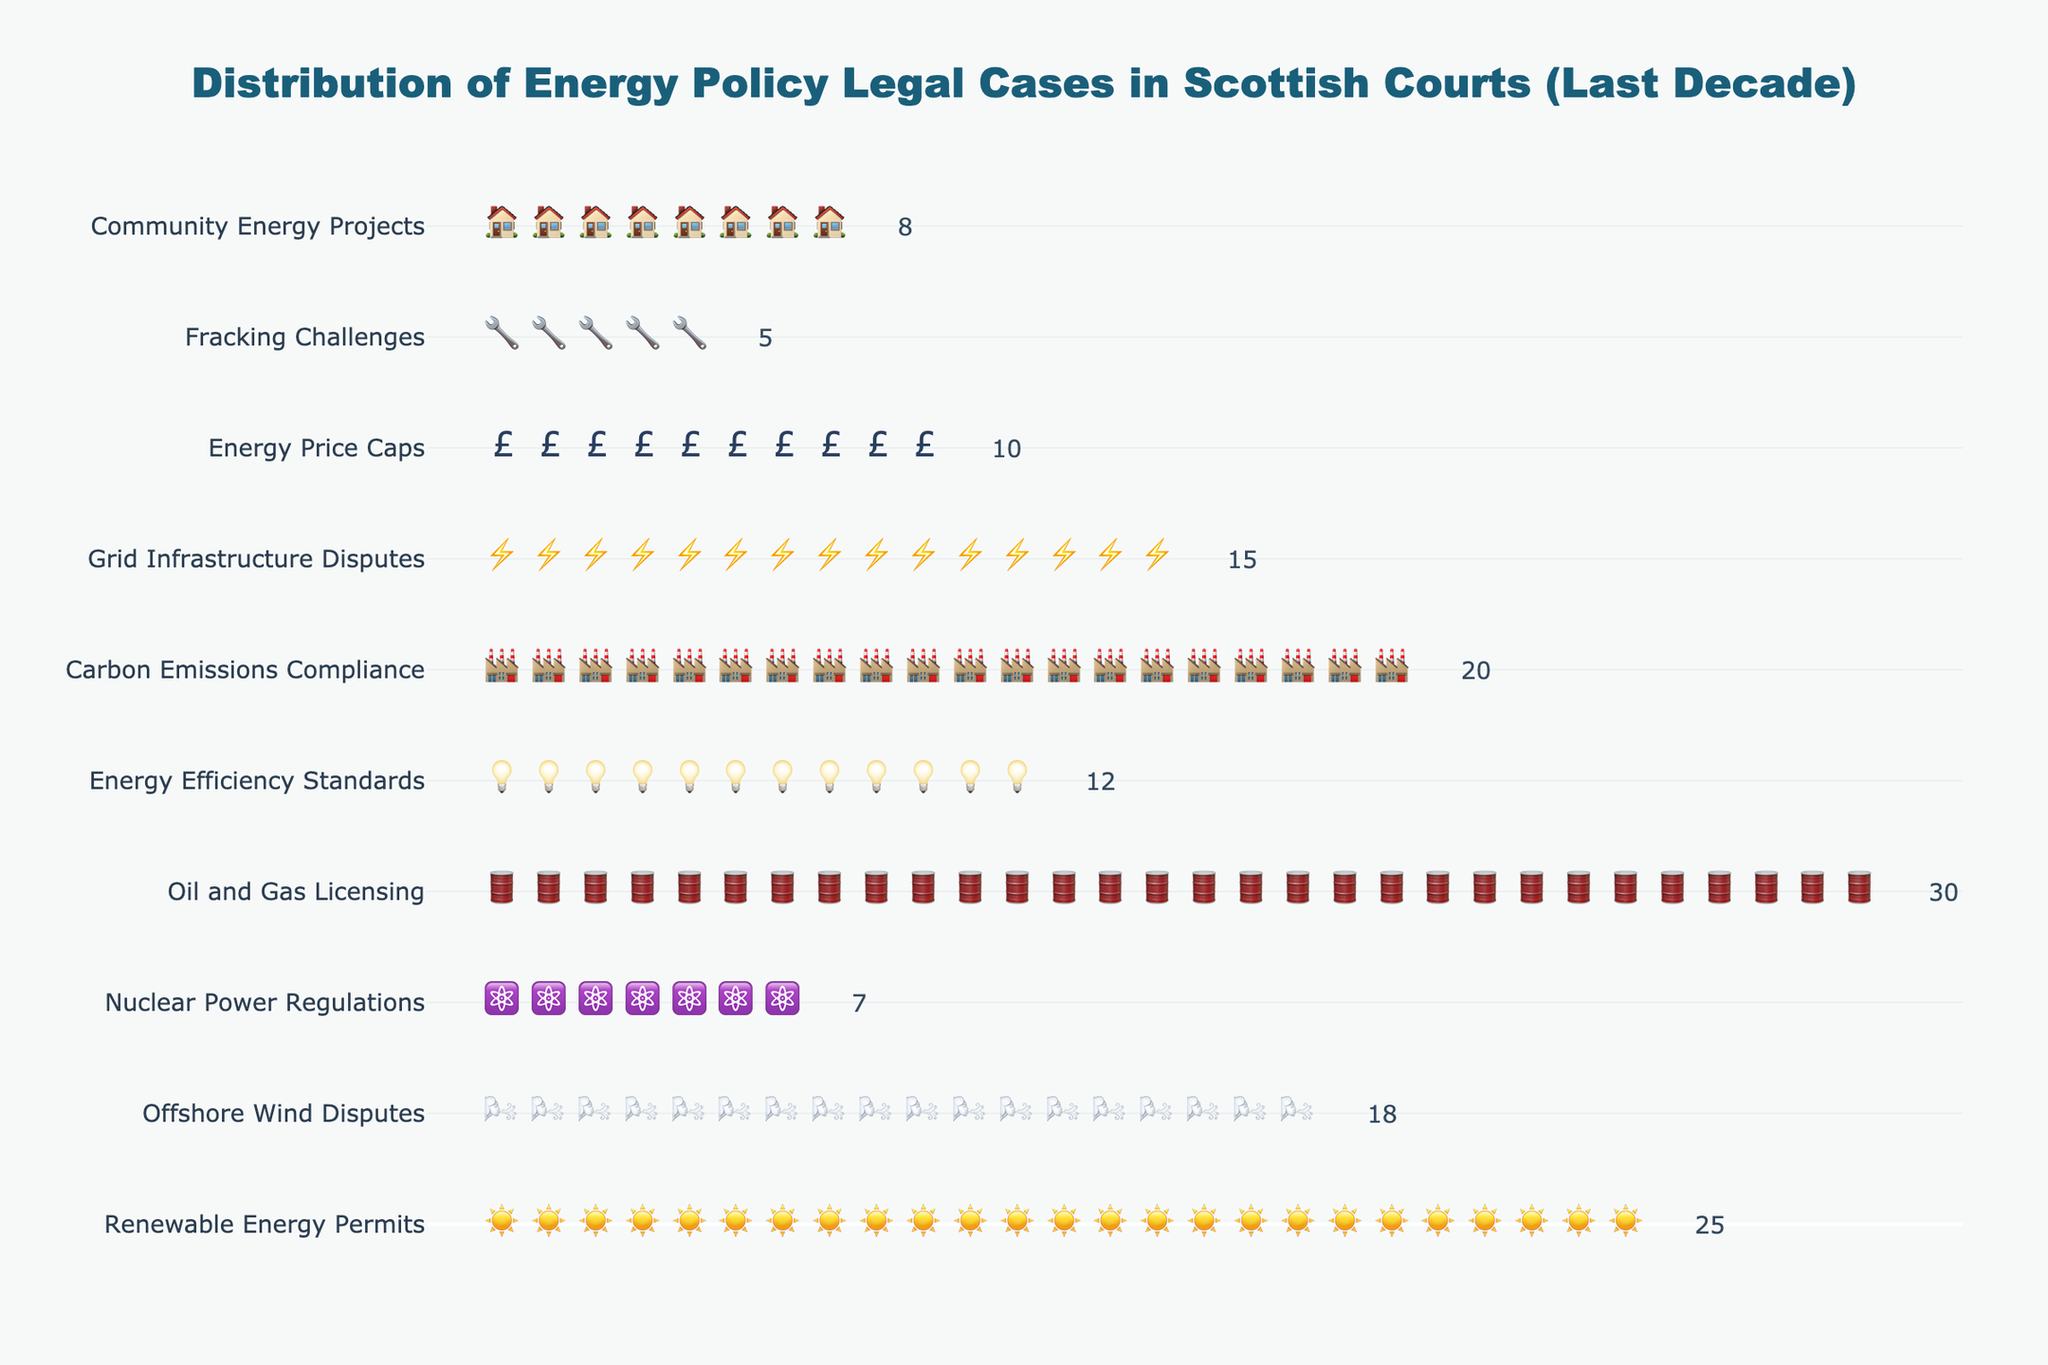Which case type has the highest number of cases? Look at the figure and identify the case type with the greatest number of icons. The "Oil and Gas Licensing" case type has 30 icons, which is the highest count.
Answer: Oil and Gas Licensing What is the total number of cases related to energy policy in Scottish courts over the past decade? Sum up the number of cases for all listed case types: 25 + 18 + 7 + 30 + 12 + 20 + 15 + 10 + 5 + 8. The total is 150.
Answer: 150 How many more cases are there for Oil and Gas Licensing compared to Fracking Challenges? Identify the number of cases for both categories: Oil and Gas Licensing has 30 cases, and Fracking Challenges has 5 cases. The difference is 30 - 5 = 25.
Answer: 25 Which icon represents the Renewable Energy Permits case type? Check the icon associated with the "Renewable Energy Permits" in the figure. The icon is a solar panel (☀️).
Answer: ☀️ (solar panel) Are there more cases related to Carbon Emissions Compliance or Energy Efficiency Standards? Compare the number of cases for both categories: Carbon Emissions Compliance has 20 cases, and Energy Efficiency Standards has 12 cases. Carbon Emissions Compliance has more cases.
Answer: Carbon Emissions Compliance What is the average number of cases per case type? Calculate the average by dividing the total number of cases by the number of case types: 150 cases / 10 case types = 15 cases per case type.
Answer: 15 Which two case types have the same number of cases? Identify any pairs with the same number of icons: Offshore Wind Disputes has 18 cases, and Carbon Emissions Compliance has 20 cases, however, no same number pairs are found: This question is a trick.
Answer: None How many case types have more than 15 cases? Count the number of case types with greater than 15 cases: Oil and Gas Licensing (30 cases), Renewable Energy Permits (25 cases), Carbon Emissions Compliance (20 cases), and Offshore Wind Disputes (18 cases). There are 4 case types with more than 15 cases.
Answer: 4 Which case type has the least number of cases? Look at the figure and find the case type with the smallest number of icons. The "Fracking Challenges" case type has 5 cases, which is the least.
Answer: Fracking Challenges What fraction of the total cases are related to Offshore Wind Disputes? Calculate the fraction by dividing the number of cases for Offshore Wind Disputes by the total number of cases: 18 / 150 = 0.12. Therefore, Offshore Wind Disputes account for 12% of the total cases.
Answer: 12% 